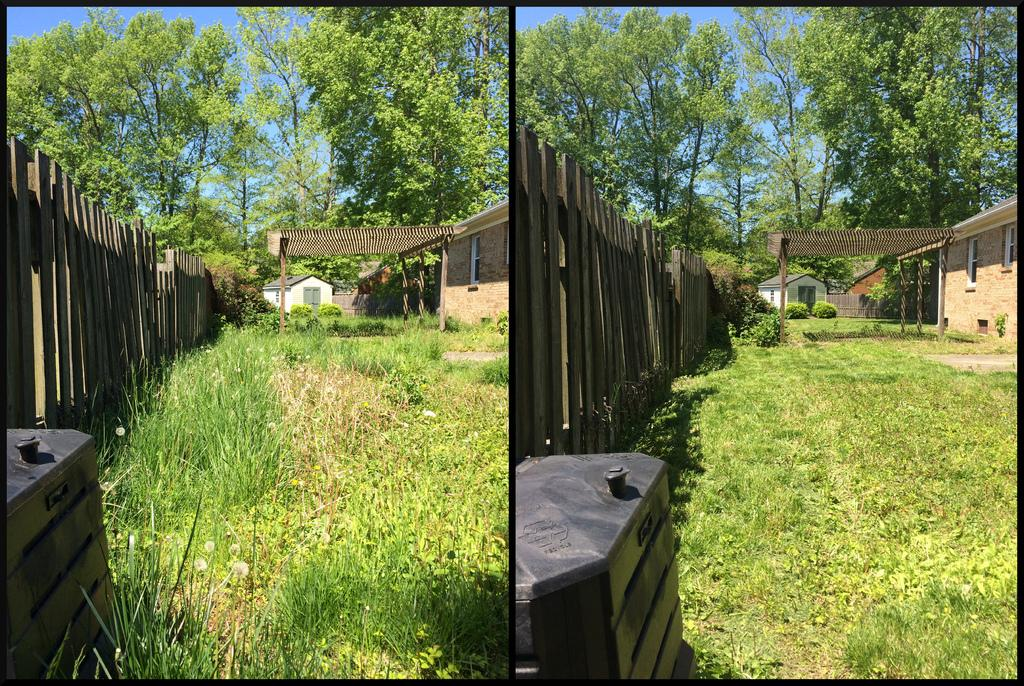What type of structures are present in the collage? There are houses in the collage. What architectural feature can be seen in the collage? There is a roof with poles in the collage. What type of vegetation is present in the collage? There are plants, grass, and a group of trees in the collage. What type of container is visible in the collage? There is a container in the collage. What part of the natural environment is visible in the collage? The sky is visible in the collage. How many dogs are playing in the bushes in the collage? There are no dogs or bushes present in the collage. What type of wheel can be seen in the collage? There is no wheel present in the collage. 